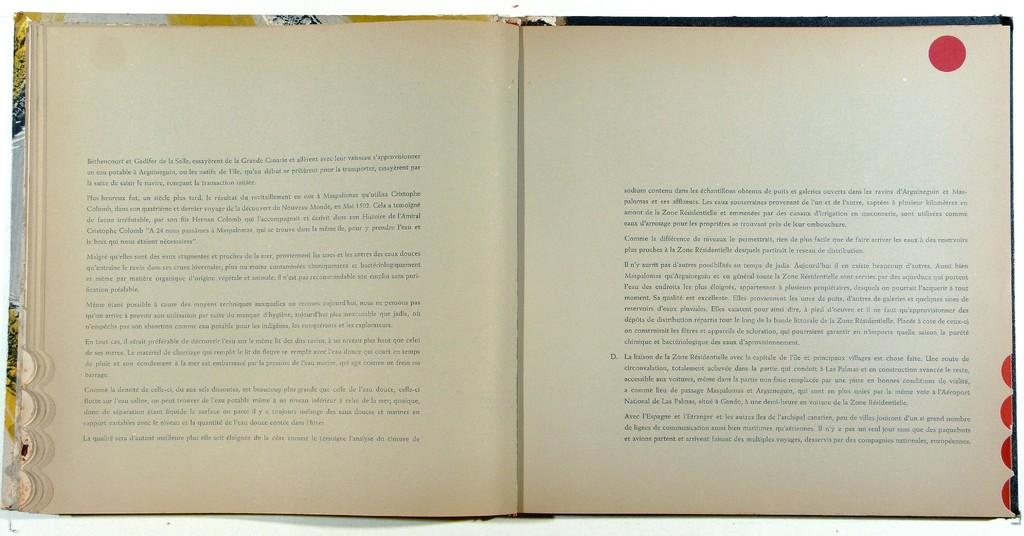What object can be seen in the image? There is a book in the image. What can be found on the book? Something is written on the book. What colors are present in the book's paper? The paper of the book is in white and cream color. Is there any noticeable marking on the book? Yes, there is a red color dot on the book. What type of birds can be seen flying around the book in the image? There are no birds present in the image; it only features a book with writing and a red color dot. 